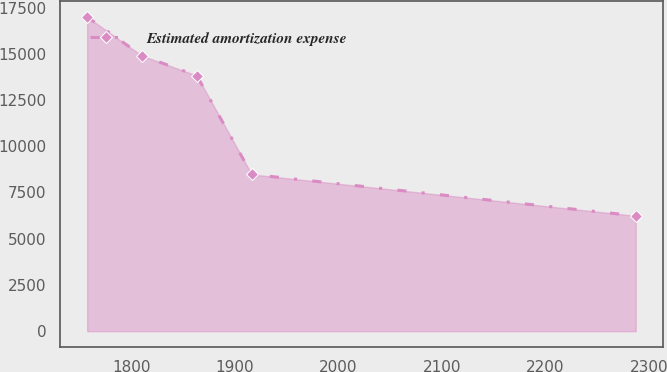Convert chart. <chart><loc_0><loc_0><loc_500><loc_500><line_chart><ecel><fcel>Estimated amortization expense<nl><fcel>1757.02<fcel>16995.1<nl><fcel>1810.05<fcel>14895.6<nl><fcel>1863.08<fcel>13819.8<nl><fcel>1916.11<fcel>8478.05<nl><fcel>2287.31<fcel>6237.02<nl></chart> 